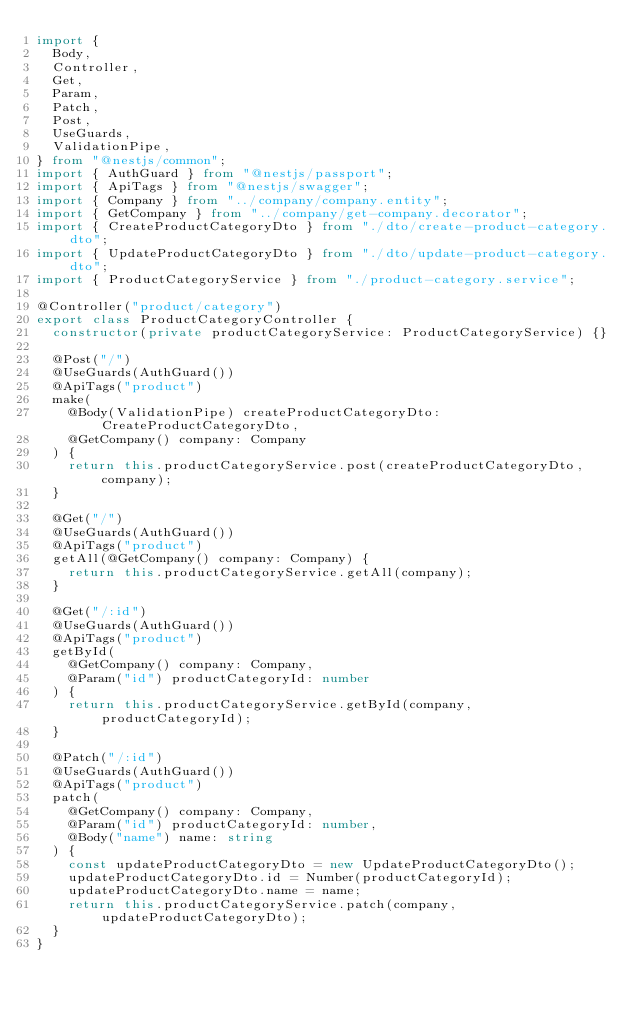<code> <loc_0><loc_0><loc_500><loc_500><_TypeScript_>import {
  Body,
  Controller,
  Get,
  Param,
  Patch,
  Post,
  UseGuards,
  ValidationPipe,
} from "@nestjs/common";
import { AuthGuard } from "@nestjs/passport";
import { ApiTags } from "@nestjs/swagger";
import { Company } from "../company/company.entity";
import { GetCompany } from "../company/get-company.decorator";
import { CreateProductCategoryDto } from "./dto/create-product-category.dto";
import { UpdateProductCategoryDto } from "./dto/update-product-category.dto";
import { ProductCategoryService } from "./product-category.service";

@Controller("product/category")
export class ProductCategoryController {
  constructor(private productCategoryService: ProductCategoryService) {}

  @Post("/")
  @UseGuards(AuthGuard())
  @ApiTags("product")
  make(
    @Body(ValidationPipe) createProductCategoryDto: CreateProductCategoryDto,
    @GetCompany() company: Company
  ) {
    return this.productCategoryService.post(createProductCategoryDto, company);
  }

  @Get("/")
  @UseGuards(AuthGuard())
  @ApiTags("product")
  getAll(@GetCompany() company: Company) {
    return this.productCategoryService.getAll(company);
  }

  @Get("/:id")
  @UseGuards(AuthGuard())
  @ApiTags("product")
  getById(
    @GetCompany() company: Company,
    @Param("id") productCategoryId: number
  ) {
    return this.productCategoryService.getById(company, productCategoryId);
  }

  @Patch("/:id")
  @UseGuards(AuthGuard())
  @ApiTags("product")
  patch(
    @GetCompany() company: Company,
    @Param("id") productCategoryId: number,
    @Body("name") name: string
  ) {
    const updateProductCategoryDto = new UpdateProductCategoryDto();
    updateProductCategoryDto.id = Number(productCategoryId);
    updateProductCategoryDto.name = name;
    return this.productCategoryService.patch(company, updateProductCategoryDto);
  }
}
</code> 